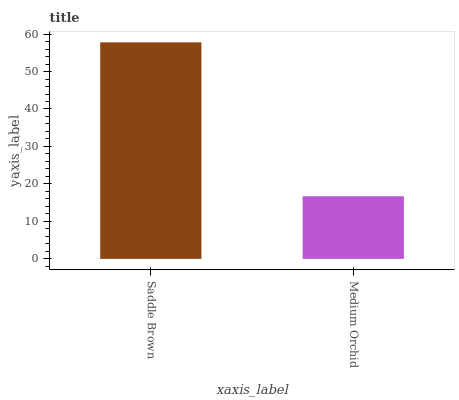Is Medium Orchid the maximum?
Answer yes or no. No. Is Saddle Brown greater than Medium Orchid?
Answer yes or no. Yes. Is Medium Orchid less than Saddle Brown?
Answer yes or no. Yes. Is Medium Orchid greater than Saddle Brown?
Answer yes or no. No. Is Saddle Brown less than Medium Orchid?
Answer yes or no. No. Is Saddle Brown the high median?
Answer yes or no. Yes. Is Medium Orchid the low median?
Answer yes or no. Yes. Is Medium Orchid the high median?
Answer yes or no. No. Is Saddle Brown the low median?
Answer yes or no. No. 